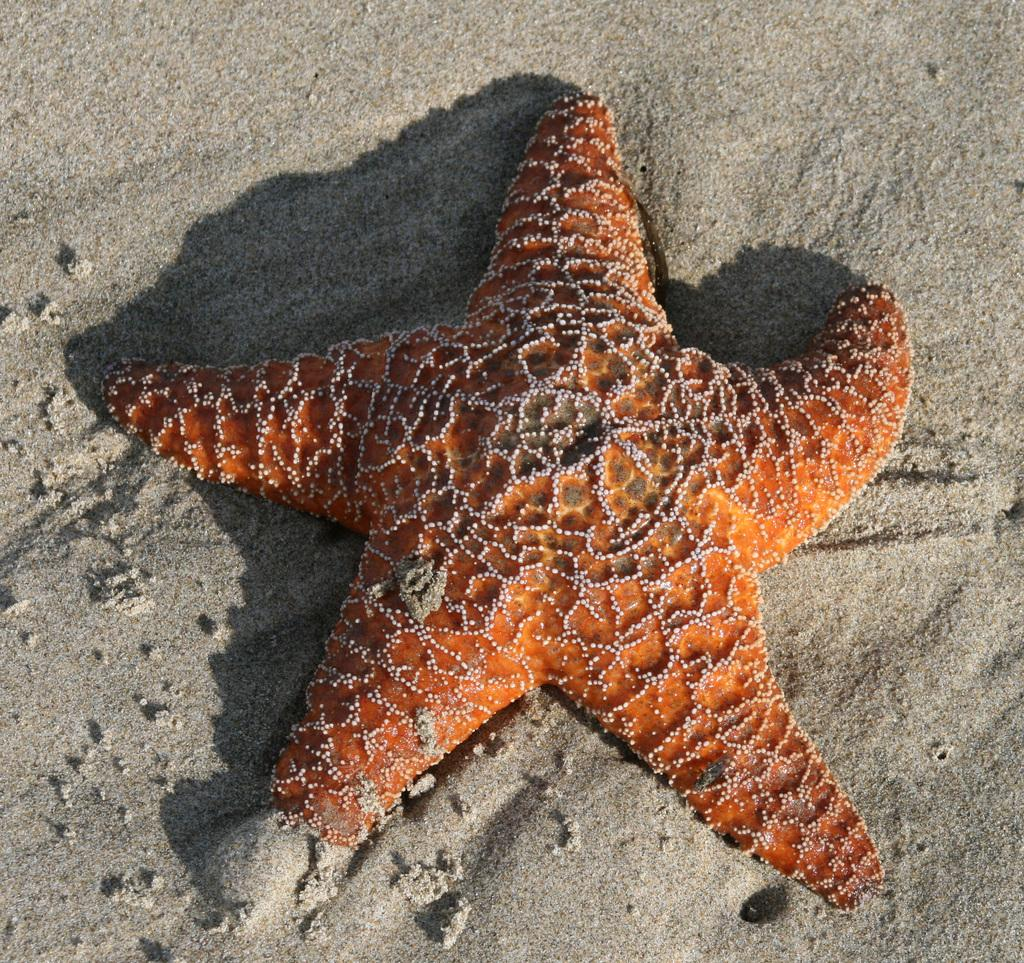What is the color of the starfish in the image? The starfish in the image is orange. Where is the starfish located in the image? The starfish is on the sand surface. What can be observed about the starfish's shadow in the image? There is a shadow of the starfish on the sand surface. What grade does the starfish receive for its performance in the image? There is no performance or grade associated with the starfish in the image, as it is a static object. 